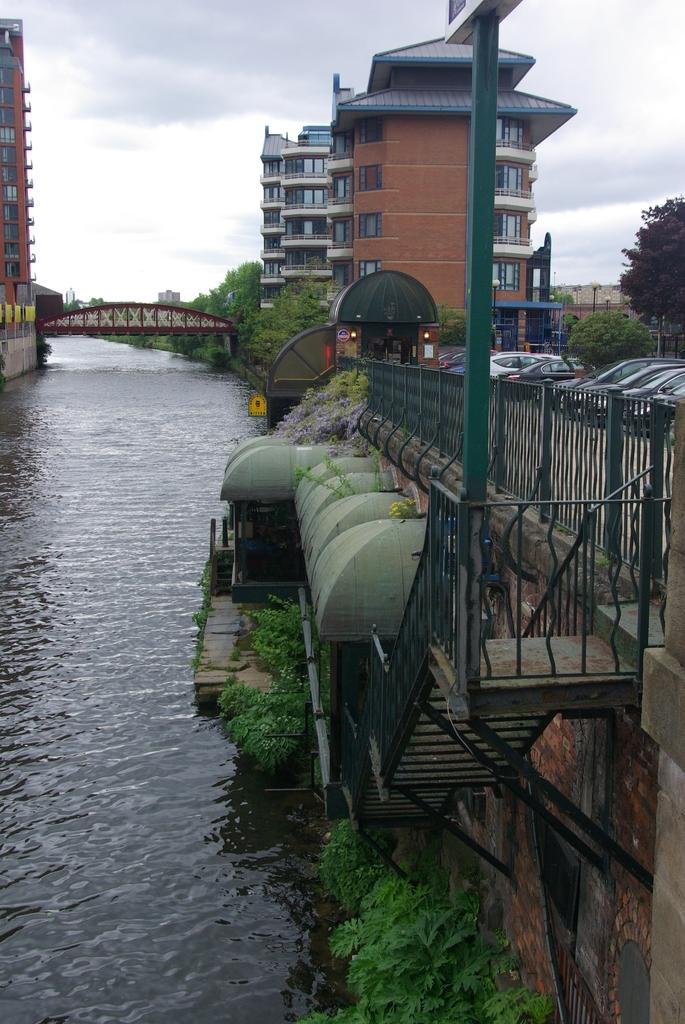What type of natural feature can be seen in the image? There is a lake in the image. What man-made structure is present in the image? There is a bridge in the image. What type of barrier can be seen in the image? There is a fence in the image. What type of transportation is visible in the image? Cars and vehicles are visible in the image. What type of building is present in the image? There is a building in the image. What type of vertical structure is present in the image? A pole is present in the image. What type of architectural feature is present in the image? There is a staircase in the image. What is visible at the top of the image? The sky is visible at the top of the image. How many dinosaurs are visible in the image? There are no dinosaurs present in the image. What type of nail is being used to hold the building together in the image? There is no nail visible in the image, and the building's construction is not described. 